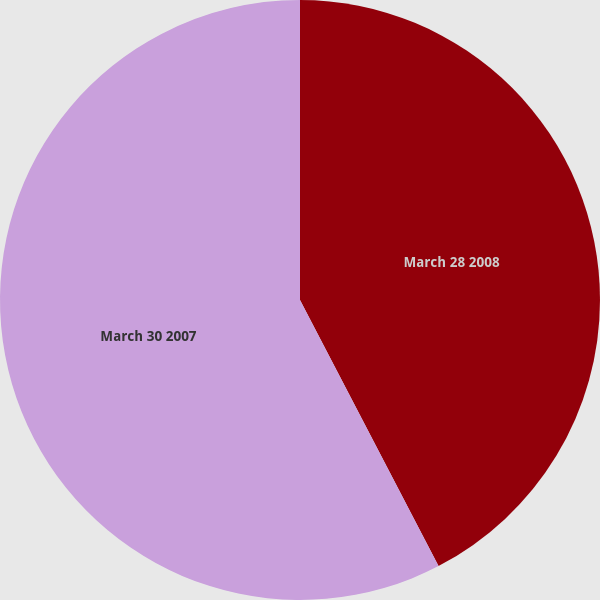Convert chart to OTSL. <chart><loc_0><loc_0><loc_500><loc_500><pie_chart><fcel>March 28 2008<fcel>March 30 2007<nl><fcel>42.36%<fcel>57.64%<nl></chart> 